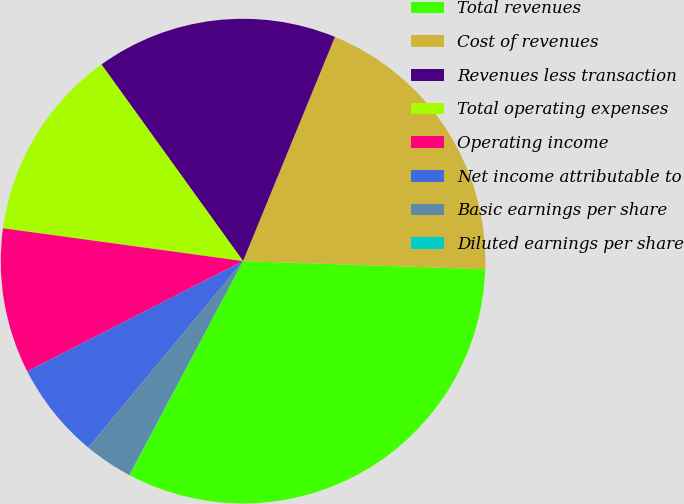Convert chart to OTSL. <chart><loc_0><loc_0><loc_500><loc_500><pie_chart><fcel>Total revenues<fcel>Cost of revenues<fcel>Revenues less transaction<fcel>Total operating expenses<fcel>Operating income<fcel>Net income attributable to<fcel>Basic earnings per share<fcel>Diluted earnings per share<nl><fcel>32.22%<fcel>19.34%<fcel>16.12%<fcel>12.9%<fcel>9.68%<fcel>6.46%<fcel>3.24%<fcel>0.02%<nl></chart> 